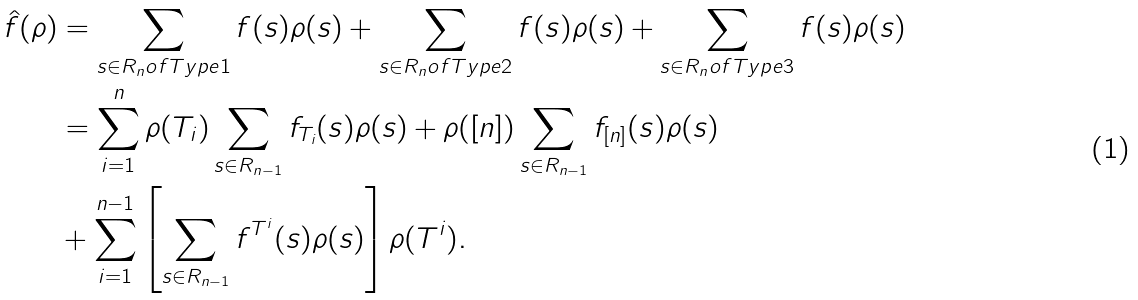<formula> <loc_0><loc_0><loc_500><loc_500>\hat { f } ( \rho ) & = \sum _ { s \in R _ { n } o f T y p e 1 } f ( s ) \rho ( s ) + \sum _ { s \in R _ { n } o f T y p e 2 } f ( s ) \rho ( s ) + \sum _ { s \in R _ { n } o f T y p e 3 } f ( s ) \rho ( s ) \\ & = \sum _ { i = 1 } ^ { n } \rho ( T _ { i } ) \sum _ { s \in R _ { n - 1 } } f _ { T _ { i } } ( s ) \rho ( s ) + \rho ( [ n ] ) \sum _ { s \in R _ { n - 1 } } f _ { [ n ] } ( s ) \rho ( s ) \\ & + \sum _ { i = 1 } ^ { n - 1 } \left [ \sum _ { s \in R _ { n - 1 } } f ^ { T ^ { i } } ( s ) \rho ( s ) \right ] \rho ( T ^ { i } ) .</formula> 